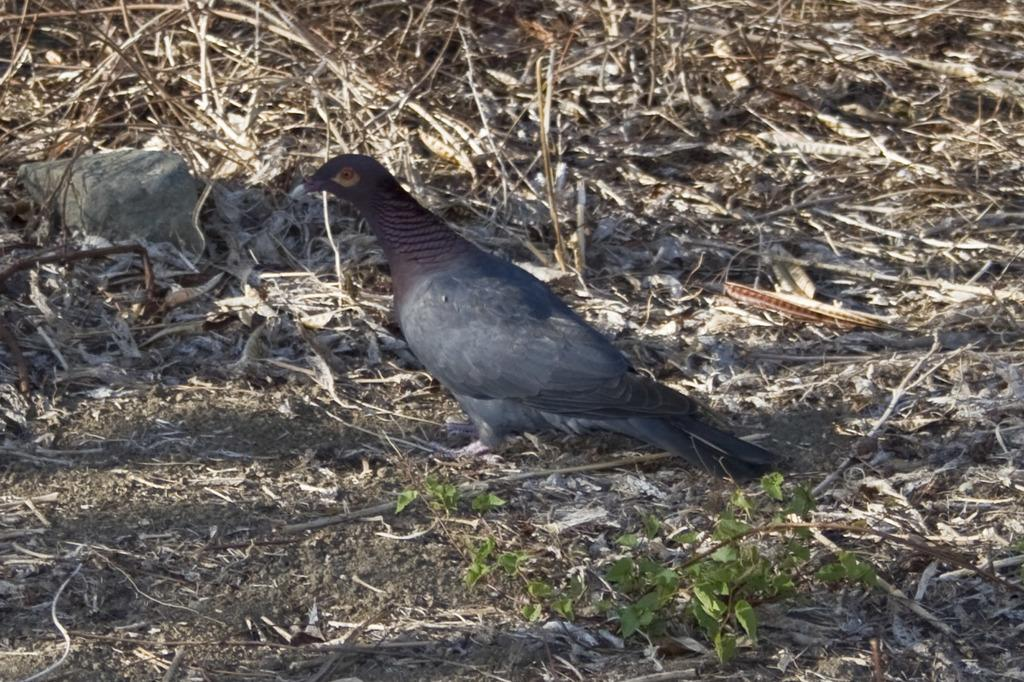What is the main subject in the center of the image? There is a bird in the center of the image. What can be seen on the ground in the image? There are dry leaves and a stone on the ground. How many people are in the crowd surrounding the bird in the image? There is no crowd present in the image; it only features a bird, dry leaves, and a stone on the ground. 